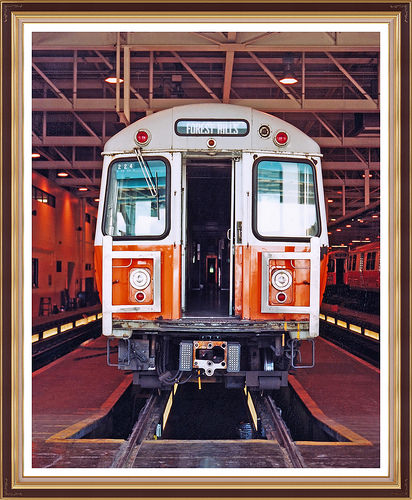<image>
Is there a train on the track? Yes. Looking at the image, I can see the train is positioned on top of the track, with the track providing support. 